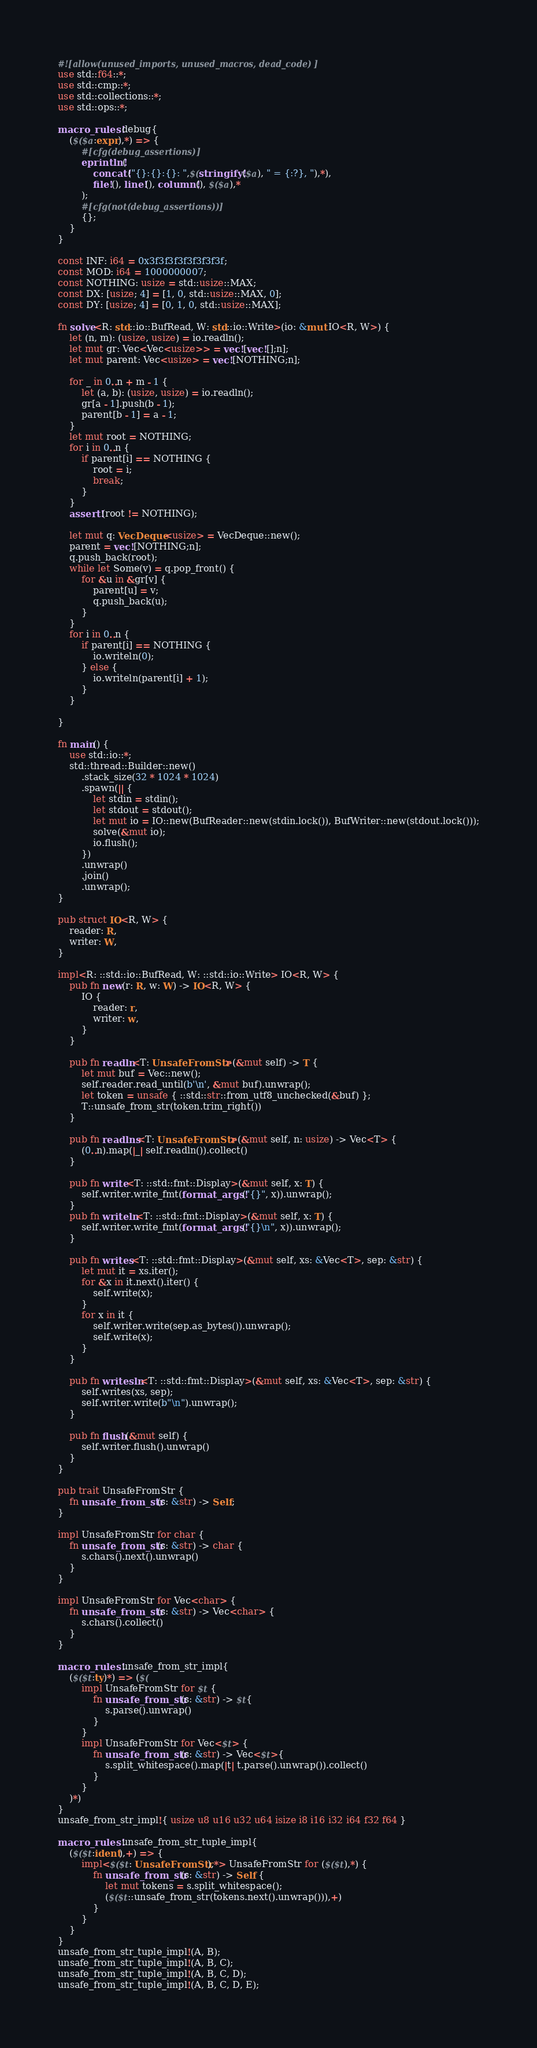Convert code to text. <code><loc_0><loc_0><loc_500><loc_500><_Rust_>#![allow(unused_imports, unused_macros, dead_code)]
use std::f64::*;
use std::cmp::*;
use std::collections::*;
use std::ops::*;

macro_rules! debug{
    ($($a:expr),*) => {
        #[cfg(debug_assertions)]
        eprintln!(
            concat!("{}:{}:{}: ",$(stringify!($a), " = {:?}, "),*),
            file!(), line!(), column!(), $($a),*
        );
        #[cfg(not(debug_assertions))]
        {};
    }
}

const INF: i64 = 0x3f3f3f3f3f3f3f3f;
const MOD: i64 = 1000000007;
const NOTHING: usize = std::usize::MAX;
const DX: [usize; 4] = [1, 0, std::usize::MAX, 0];
const DY: [usize; 4] = [0, 1, 0, std::usize::MAX];

fn solve<R: std::io::BufRead, W: std::io::Write>(io: &mut IO<R, W>) {
    let (n, m): (usize, usize) = io.readln();
    let mut gr: Vec<Vec<usize>> = vec![vec![];n];
    let mut parent: Vec<usize> = vec![NOTHING;n];

    for _ in 0..n + m - 1 {
        let (a, b): (usize, usize) = io.readln();
        gr[a - 1].push(b - 1);
        parent[b - 1] = a - 1;
    }
    let mut root = NOTHING;
    for i in 0..n {
        if parent[i] == NOTHING {
            root = i;
            break;
        }
    }
    assert!(root != NOTHING);

    let mut q: VecDeque<usize> = VecDeque::new();
    parent = vec![NOTHING;n];
    q.push_back(root);
    while let Some(v) = q.pop_front() {
        for &u in &gr[v] {
            parent[u] = v;
            q.push_back(u);
        }
    }
    for i in 0..n {
        if parent[i] == NOTHING {
            io.writeln(0);
        } else {
            io.writeln(parent[i] + 1);
        }
    }

}

fn main() {
    use std::io::*;
    std::thread::Builder::new()
        .stack_size(32 * 1024 * 1024)
        .spawn(|| {
            let stdin = stdin();
            let stdout = stdout();
            let mut io = IO::new(BufReader::new(stdin.lock()), BufWriter::new(stdout.lock()));
            solve(&mut io);
            io.flush();
        })
        .unwrap()
        .join()
        .unwrap();
}

pub struct IO<R, W> {
    reader: R,
    writer: W,
}

impl<R: ::std::io::BufRead, W: ::std::io::Write> IO<R, W> {
    pub fn new(r: R, w: W) -> IO<R, W> {
        IO {
            reader: r,
            writer: w,
        }
    }

    pub fn readln<T: UnsafeFromStr>(&mut self) -> T {
        let mut buf = Vec::new();
        self.reader.read_until(b'\n', &mut buf).unwrap();
        let token = unsafe { ::std::str::from_utf8_unchecked(&buf) };
        T::unsafe_from_str(token.trim_right())
    }

    pub fn readlns<T: UnsafeFromStr>(&mut self, n: usize) -> Vec<T> {
        (0..n).map(|_| self.readln()).collect()
    }

    pub fn write<T: ::std::fmt::Display>(&mut self, x: T) {
        self.writer.write_fmt(format_args!("{}", x)).unwrap();
    }
    pub fn writeln<T: ::std::fmt::Display>(&mut self, x: T) {
        self.writer.write_fmt(format_args!("{}\n", x)).unwrap();
    }

    pub fn writes<T: ::std::fmt::Display>(&mut self, xs: &Vec<T>, sep: &str) {
        let mut it = xs.iter();
        for &x in it.next().iter() {
            self.write(x);
        }
        for x in it {
            self.writer.write(sep.as_bytes()).unwrap();
            self.write(x);
        }
    }

    pub fn writesln<T: ::std::fmt::Display>(&mut self, xs: &Vec<T>, sep: &str) {
        self.writes(xs, sep);
        self.writer.write(b"\n").unwrap();
    }

    pub fn flush(&mut self) {
        self.writer.flush().unwrap()
    }
}

pub trait UnsafeFromStr {
    fn unsafe_from_str(s: &str) -> Self;
}

impl UnsafeFromStr for char {
    fn unsafe_from_str(s: &str) -> char {
        s.chars().next().unwrap()
    }
}

impl UnsafeFromStr for Vec<char> {
    fn unsafe_from_str(s: &str) -> Vec<char> {
        s.chars().collect()
    }
}

macro_rules! unsafe_from_str_impl{
    ($($t:ty)*) => ($(
        impl UnsafeFromStr for $t {
            fn unsafe_from_str(s: &str) -> $t{
                s.parse().unwrap()
            }
        }
        impl UnsafeFromStr for Vec<$t> {
            fn unsafe_from_str(s: &str) -> Vec<$t>{
                s.split_whitespace().map(|t| t.parse().unwrap()).collect()
            }
        }
    )*)
}
unsafe_from_str_impl!{ usize u8 u16 u32 u64 isize i8 i16 i32 i64 f32 f64 }

macro_rules! unsafe_from_str_tuple_impl{
    ($($t:ident),+) => {
        impl<$($t: UnsafeFromStr),*> UnsafeFromStr for ($($t),*) {
            fn unsafe_from_str(s: &str) -> Self {
                let mut tokens = s.split_whitespace();
                ($($t::unsafe_from_str(tokens.next().unwrap())),+)
            }
        }
    }
}
unsafe_from_str_tuple_impl!(A, B);
unsafe_from_str_tuple_impl!(A, B, C);
unsafe_from_str_tuple_impl!(A, B, C, D);
unsafe_from_str_tuple_impl!(A, B, C, D, E);
</code> 